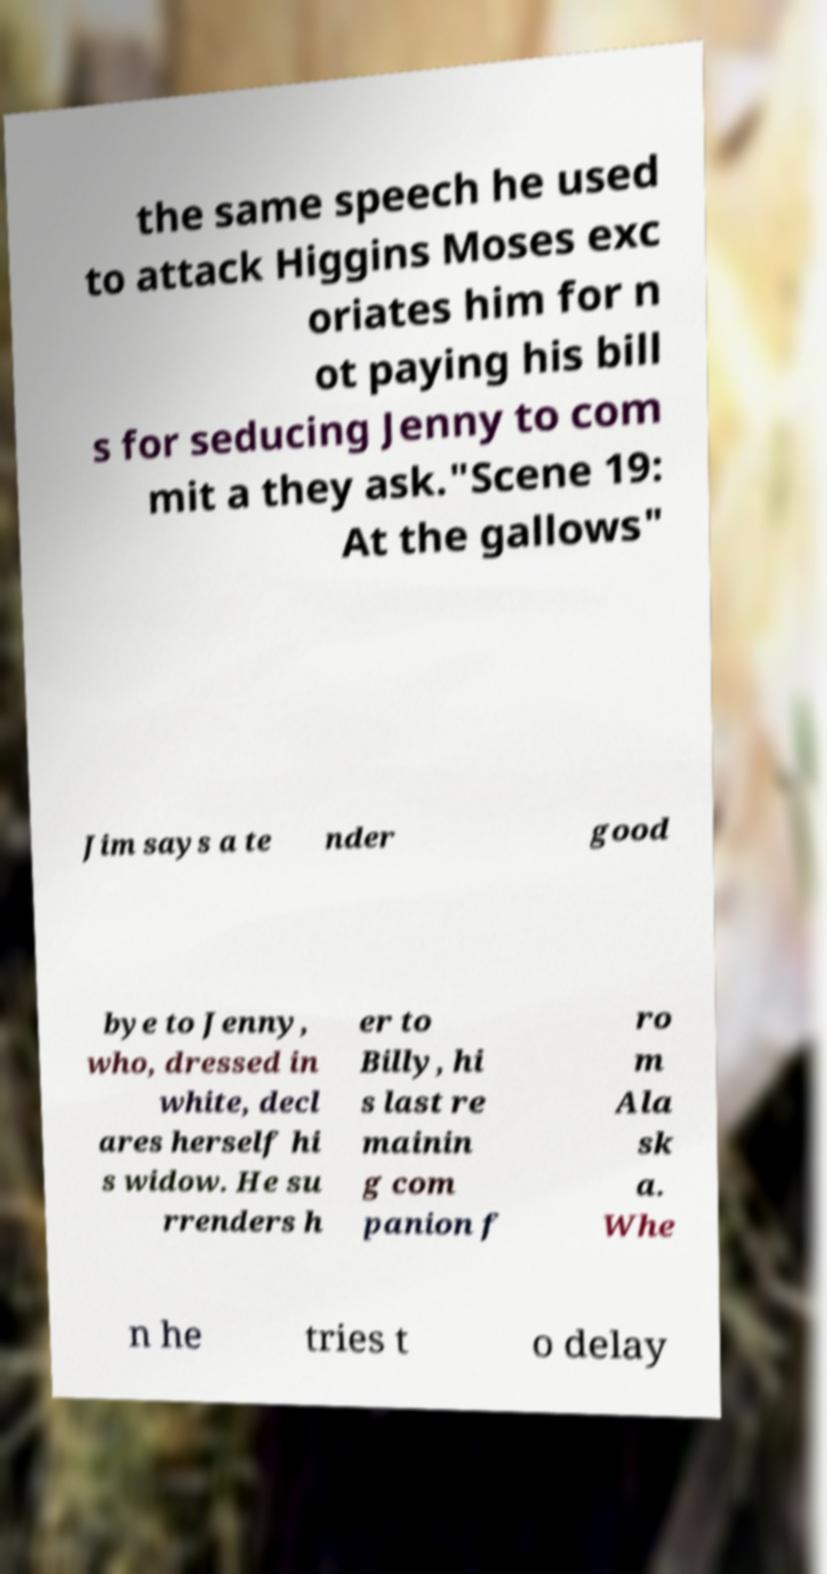Can you read and provide the text displayed in the image?This photo seems to have some interesting text. Can you extract and type it out for me? the same speech he used to attack Higgins Moses exc oriates him for n ot paying his bill s for seducing Jenny to com mit a they ask."Scene 19: At the gallows" Jim says a te nder good bye to Jenny, who, dressed in white, decl ares herself hi s widow. He su rrenders h er to Billy, hi s last re mainin g com panion f ro m Ala sk a. Whe n he tries t o delay 